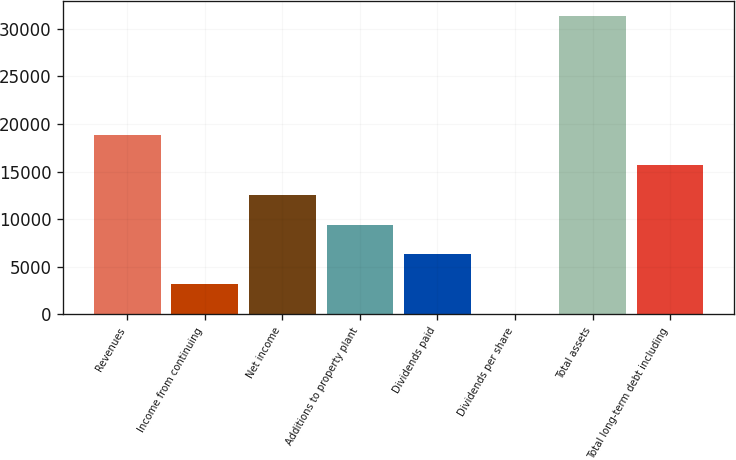Convert chart. <chart><loc_0><loc_0><loc_500><loc_500><bar_chart><fcel>Revenues<fcel>Income from continuing<fcel>Net income<fcel>Additions to property plant<fcel>Dividends paid<fcel>Dividends per share<fcel>Total assets<fcel>Total long-term debt including<nl><fcel>18822.9<fcel>3137.82<fcel>12548.9<fcel>9411.86<fcel>6274.84<fcel>0.8<fcel>31371<fcel>15685.9<nl></chart> 